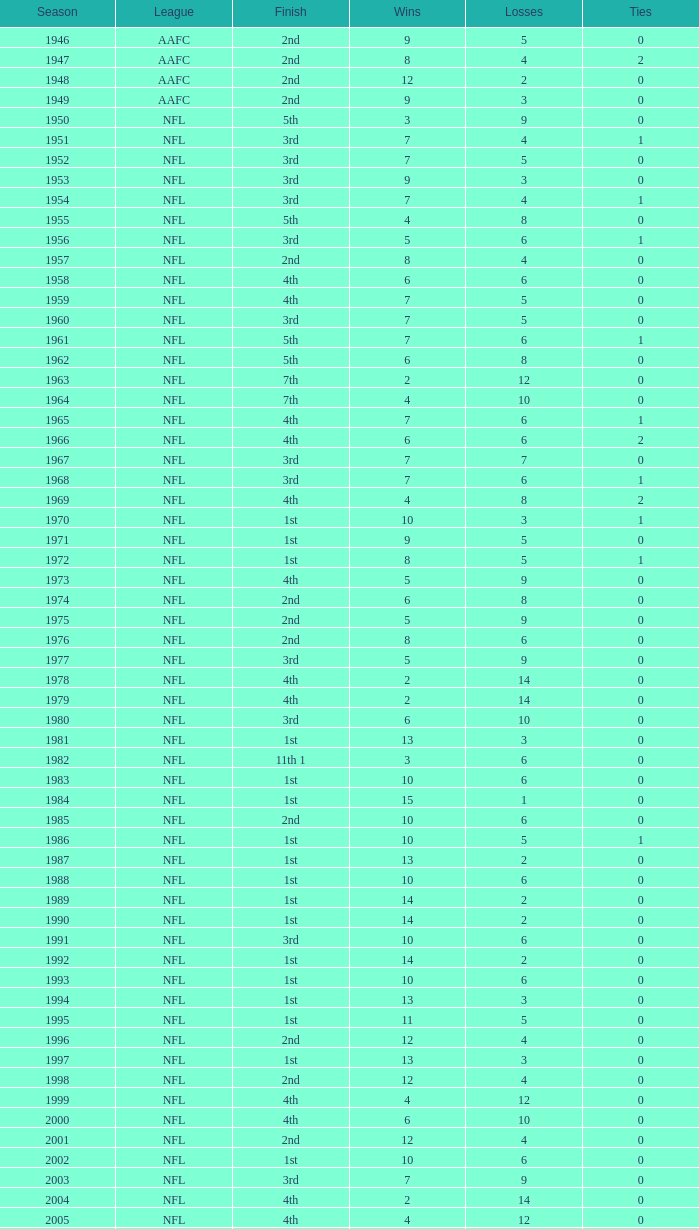When ties are below 0, what is the quantity of losses? 0.0. 